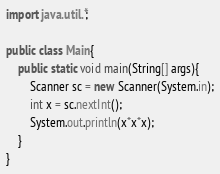<code> <loc_0><loc_0><loc_500><loc_500><_Java_>import java.util.*;

public class Main{
    public static void main(String[] args){
        Scanner sc = new Scanner(System.in);
        int x = sc.nextInt();
        System.out.println(x*x*x);
    }
}
</code> 